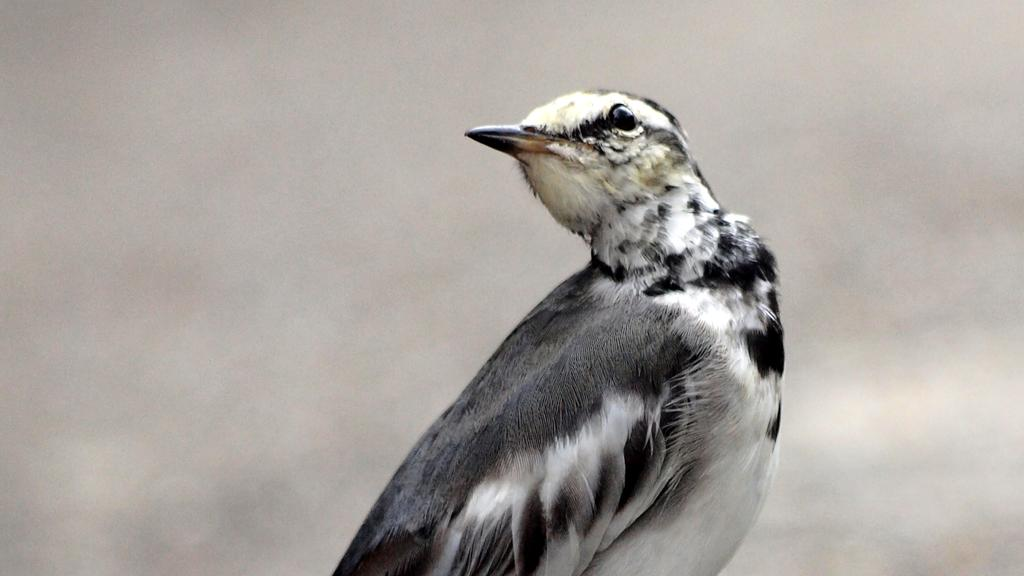What type of animal can be seen in the image? There is a bird in the image. How many mice are hiding under the bird in the image? There are no mice present in the image; it only features a bird. What type of badge is the bird wearing in the image? There is no badge present in the image, as it only features a bird. 